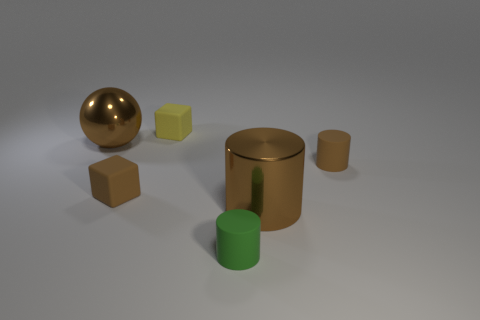Add 2 green metallic balls. How many objects exist? 8 Subtract all cubes. How many objects are left? 4 Add 1 brown shiny spheres. How many brown shiny spheres are left? 2 Add 3 green matte objects. How many green matte objects exist? 4 Subtract 1 brown balls. How many objects are left? 5 Subtract all big yellow shiny spheres. Subtract all small green matte cylinders. How many objects are left? 5 